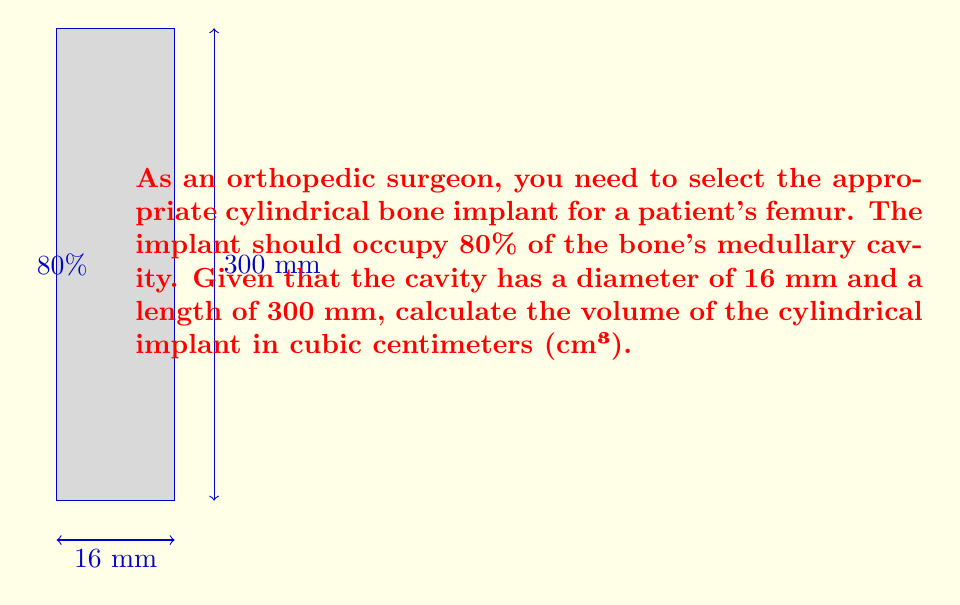Could you help me with this problem? Let's approach this step-by-step:

1) First, we need to calculate the radius of the implant. Since it should occupy 80% of the cavity's diameter:
   $r_{implant} = 0.8 \times \frac{16}{2} = 6.4$ mm

2) Convert the length from mm to cm:
   $l_{implant} = 300$ mm $= 30$ cm

3) The volume of a cylinder is given by the formula:
   $V = \pi r^2 h$

   Where $r$ is the radius and $h$ is the height (or length in this case)

4) Substituting our values:
   $V = \pi \times (0.64$ cm$)^2 \times 30$ cm

5) Calculate:
   $V = \pi \times 0.4096$ cm$^2 \times 30$ cm
   $V = 12.2880 \times 30 = 368.64$ cm³

6) Rounding to two decimal places:
   $V \approx 368.64$ cm³
Answer: $368.64$ cm³ 